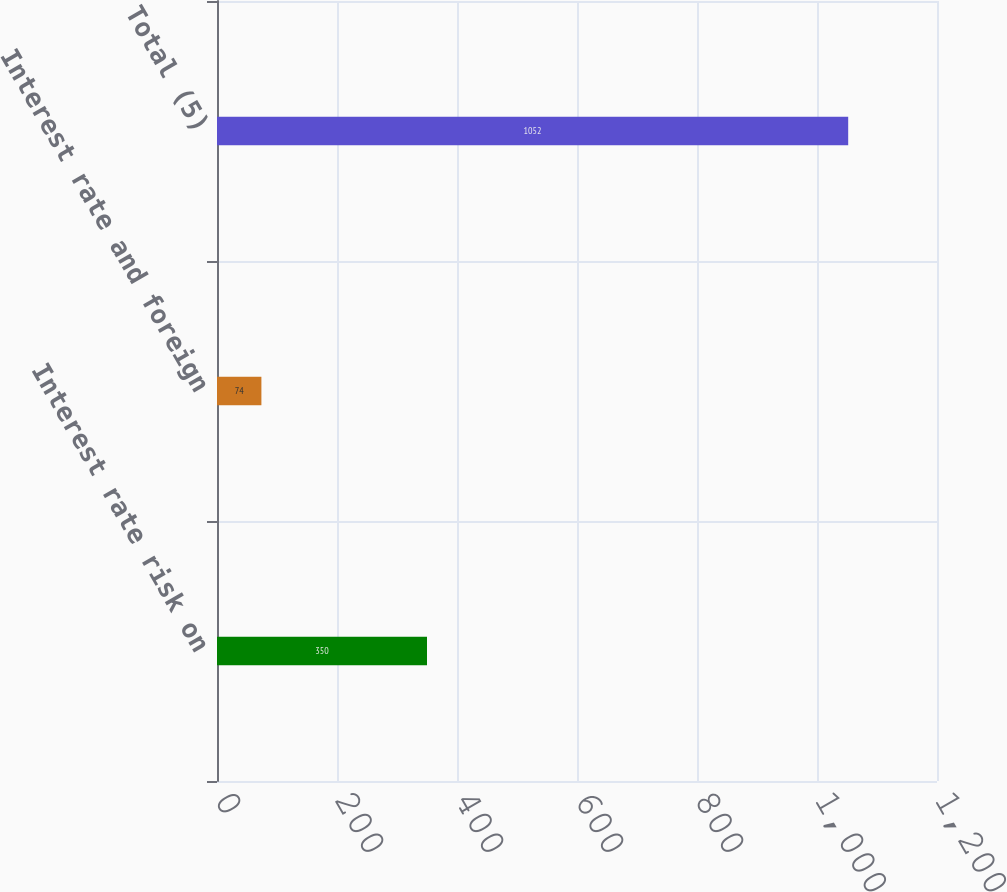<chart> <loc_0><loc_0><loc_500><loc_500><bar_chart><fcel>Interest rate risk on<fcel>Interest rate and foreign<fcel>Total (5)<nl><fcel>350<fcel>74<fcel>1052<nl></chart> 